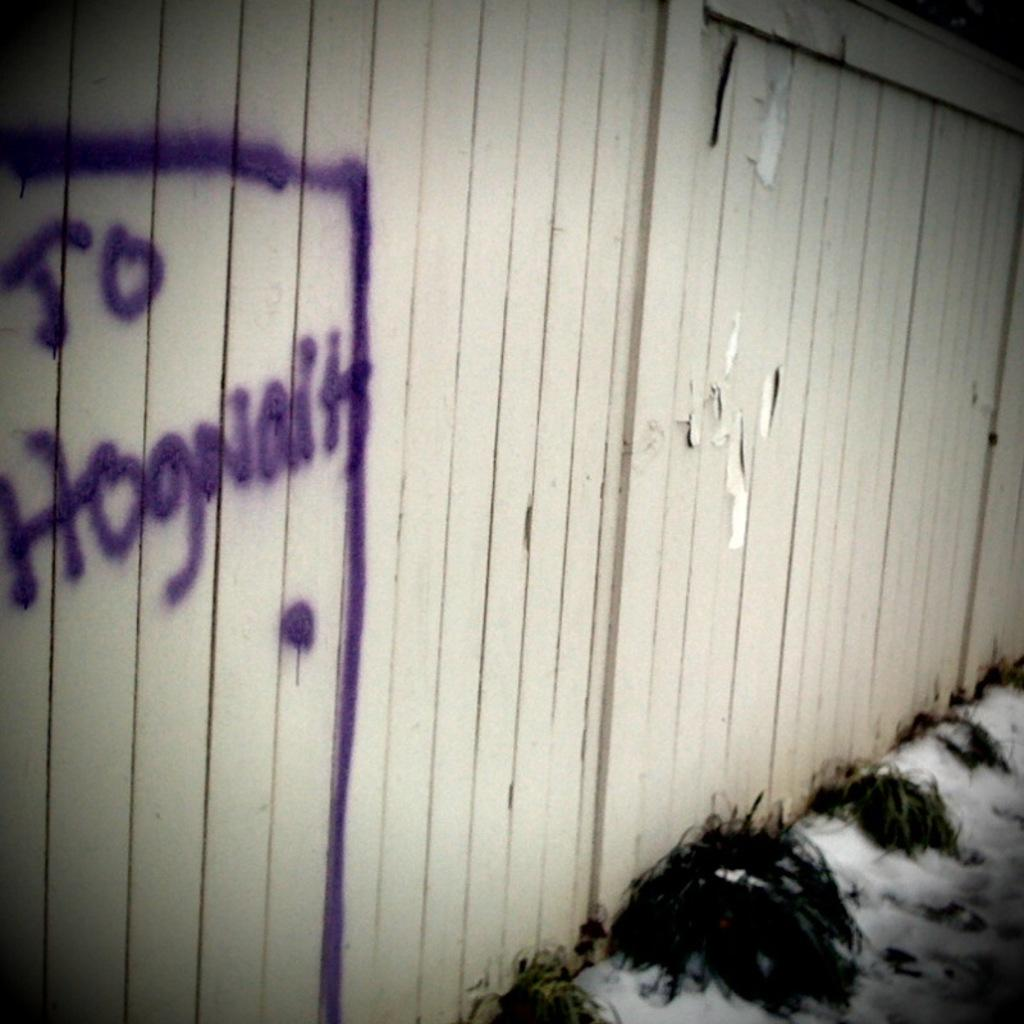What type of living organisms can be seen in the image? Plants can be seen in the image. What is the condition of the road in the image? There is ice on the road in the image. What type of barrier is present in the image? There is a wooden fence in the image. What is written on the wooden fence? There is text written on the wooden fence. What color is the text on the wooden fence? The text is violet in color. How many beads are scattered on the road in the image? There are no beads present in the image; it features plants, ice on the road, a wooden fence, and text on the fence. What type of motion can be observed in the image? The image is a still photograph, so no motion can be observed. 